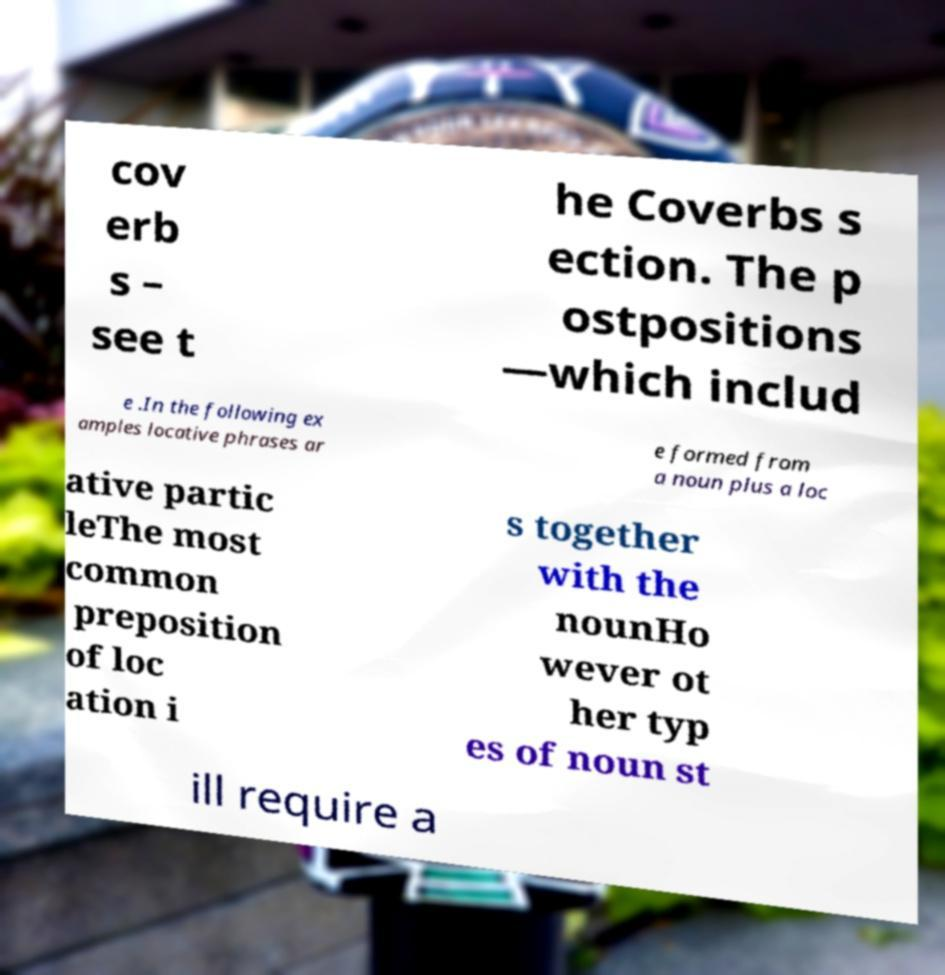What messages or text are displayed in this image? I need them in a readable, typed format. cov erb s – see t he Coverbs s ection. The p ostpositions —which includ e .In the following ex amples locative phrases ar e formed from a noun plus a loc ative partic leThe most common preposition of loc ation i s together with the nounHo wever ot her typ es of noun st ill require a 